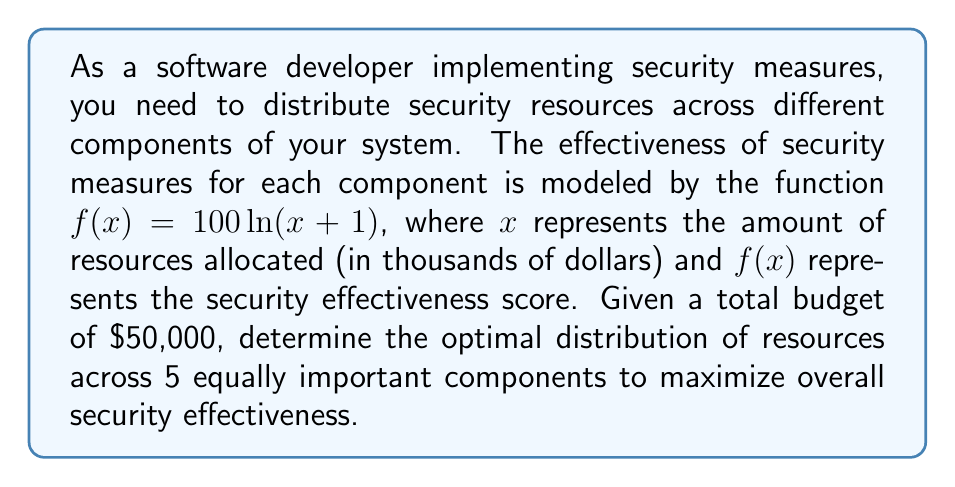Can you solve this math problem? To solve this problem, we'll use the method of Lagrange multipliers:

1) Let $x_1, x_2, x_3, x_4, x_5$ represent the resources allocated to each component.

2) Our objective function is the sum of the effectiveness for all components:
   $$F = 100\ln(x_1+1) + 100\ln(x_2+1) + 100\ln(x_3+1) + 100\ln(x_4+1) + 100\ln(x_5+1)$$

3) The constraint is the total budget:
   $$x_1 + x_2 + x_3 + x_4 + x_5 = 50$$

4) Form the Lagrangian:
   $$L = F - \lambda(x_1 + x_2 + x_3 + x_4 + x_5 - 50)$$

5) Take partial derivatives and set them equal to zero:
   $$\frac{\partial L}{\partial x_i} = \frac{100}{x_i+1} - \lambda = 0 \quad \text{for } i = 1,2,3,4,5$$

6) This gives us:
   $$x_i + 1 = \frac{100}{\lambda} \quad \text{for } i = 1,2,3,4,5$$

7) Substituting into the constraint:
   $$5(\frac{100}{\lambda} - 1) = 50$$

8) Solving for $\lambda$:
   $$\lambda = 10$$

9) Substituting back:
   $$x_i + 1 = \frac{100}{10} = 10$$
   $$x_i = 9 \quad \text{for } i = 1,2,3,4,5$$

Therefore, the optimal distribution is to allocate $\$9,000 to each of the 5 components.
Answer: $\$9,000 to each of the 5 components 